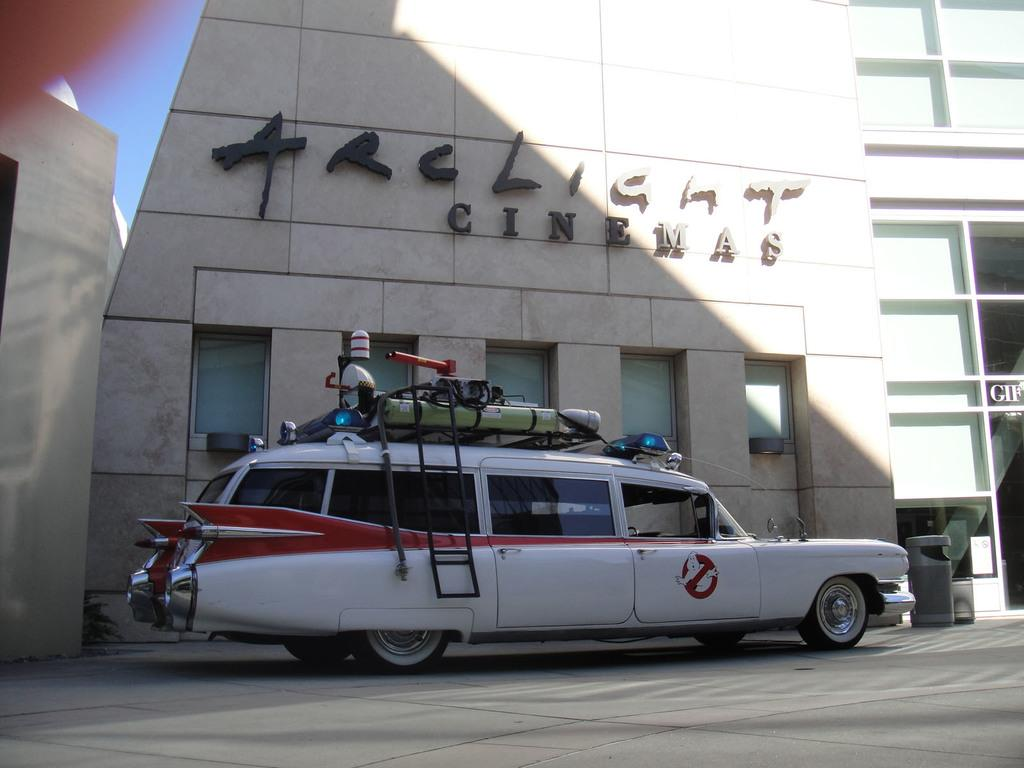What is the main subject of the image? There is a vehicle in the image. What can be seen on the vehicle? There are objects on the vehicle. What is visible in the background of the image? There is a building in the background of the image. Where is the scarecrow standing in the image? There is no scarecrow present in the image. What type of vegetable is growing near the vehicle in the image? There is no vegetable visible in the image. 